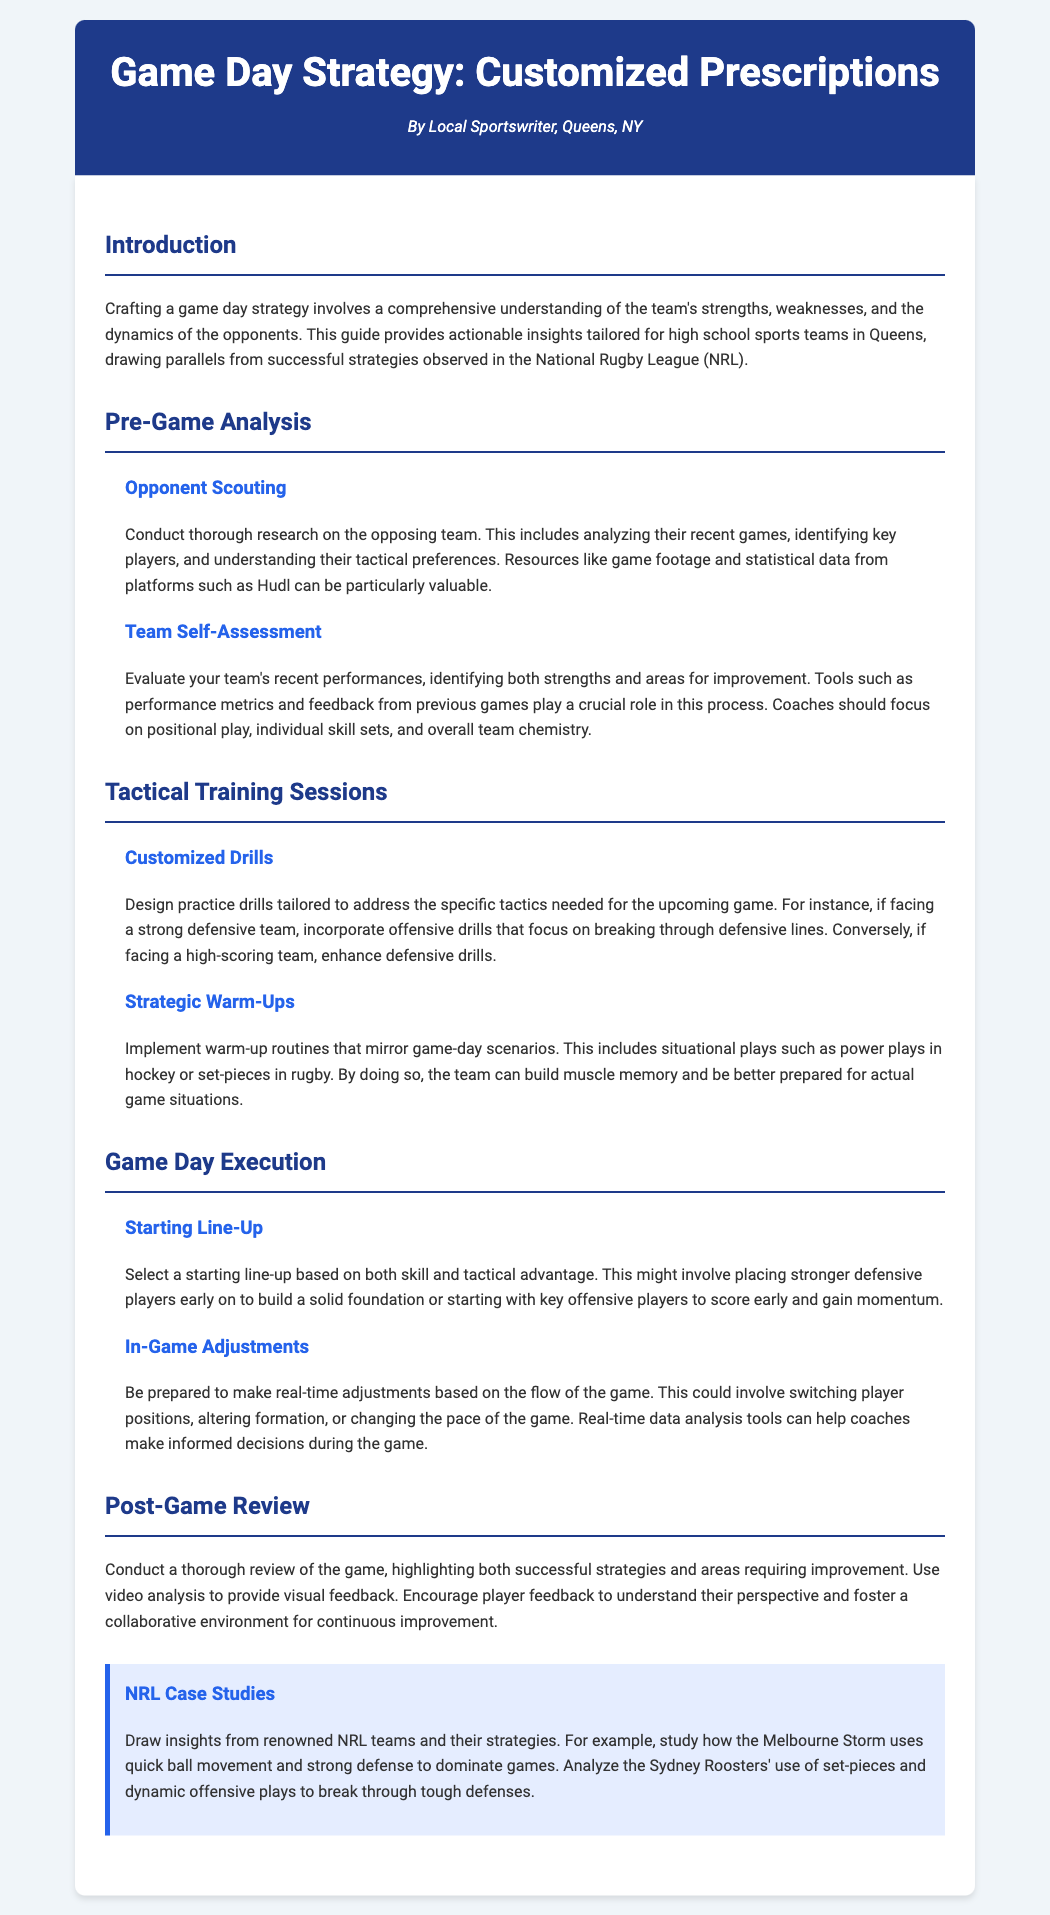what is the title of the document? The title of the document is prominently displayed in the header section as "Game Day Strategy: Customized Prescriptions."
Answer: Game Day Strategy: Customized Prescriptions who is the author of the document? The author's name is mentioned in the header section, indicating the origin of the document.
Answer: Local Sportswriter, Queens, NY what should be included in pre-game analysis? The section on Pre-Game Analysis outlines key components like opponent scouting and team self-assessment.
Answer: Opponent scouting and team self-assessment what is one example of a tactical training session mentioned? The document provides examples of customized drills and strategic warm-ups as tactical training sessions.
Answer: Customized drills what is the purpose of in-game adjustments? In-game adjustments aim to adapt strategies based on the current flow of the game for better outcomes.
Answer: Real-time adjustments how should the starting line-up be chosen? The section on Game Day Execution explains that the starting line-up should be selected based on skill and tactical advantage.
Answer: Skill and tactical advantage which NRL team is noted for its strong defense? The document mentions the Melbourne Storm as a case study for employing strong defense strategies.
Answer: Melbourne Storm what tool can aid in making real-time adjustments during a game? The document highlights the use of real-time data analysis tools to assist coaches in decision-making during games.
Answer: Real-time data analysis tools 